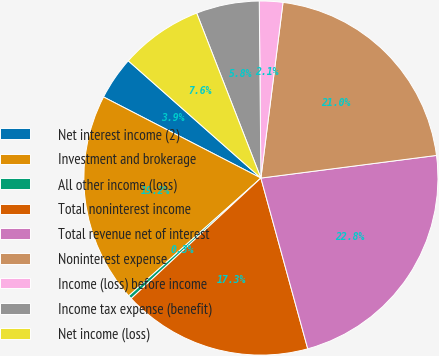Convert chart to OTSL. <chart><loc_0><loc_0><loc_500><loc_500><pie_chart><fcel>Net interest income (2)<fcel>Investment and brokerage<fcel>All other income (loss)<fcel>Total noninterest income<fcel>Total revenue net of interest<fcel>Noninterest expense<fcel>Income (loss) before income<fcel>Income tax expense (benefit)<fcel>Net income (loss)<nl><fcel>3.95%<fcel>19.16%<fcel>0.33%<fcel>17.35%<fcel>22.78%<fcel>20.97%<fcel>2.14%<fcel>5.76%<fcel>7.57%<nl></chart> 